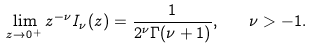Convert formula to latex. <formula><loc_0><loc_0><loc_500><loc_500>\lim _ { z \to 0 ^ { + } } z ^ { - \nu } I _ { \nu } ( z ) = \frac { 1 } { 2 ^ { \nu } \Gamma ( \nu + 1 ) } , \quad \nu > - 1 .</formula> 